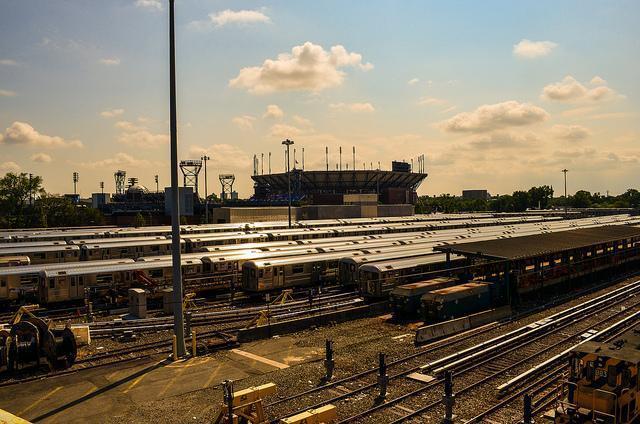How many trains are there?
Give a very brief answer. 10. How many white horses are there?
Give a very brief answer. 0. 